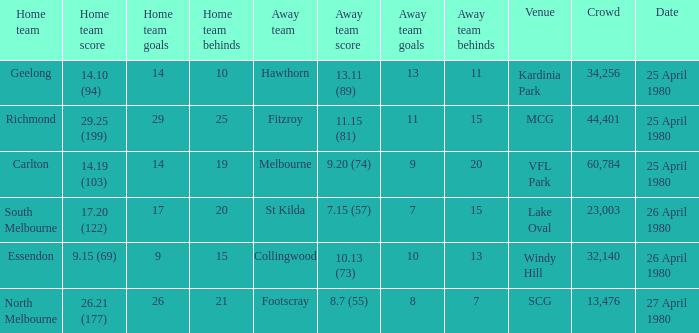On what date did the match at Lake Oval take place? 26 April 1980. 